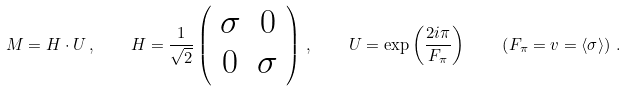Convert formula to latex. <formula><loc_0><loc_0><loc_500><loc_500>M = H \cdot U \, , \quad H = \frac { 1 } { \sqrt { 2 } } \left ( \begin{array} { c c } \sigma & 0 \\ 0 & \sigma \end{array} \right ) \, , \quad U = \exp \left ( \frac { 2 i \pi } { F _ { \pi } } \right ) \quad \left ( F _ { \pi } = v = \langle \sigma \rangle \right ) \, .</formula> 